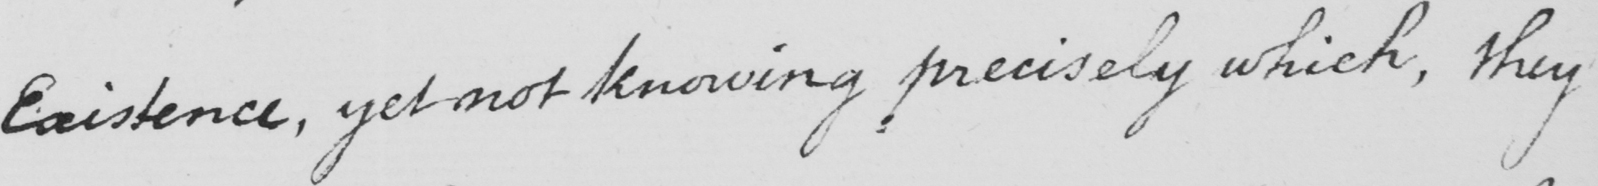What is written in this line of handwriting? Existence, yet not knowing precisely which, they 